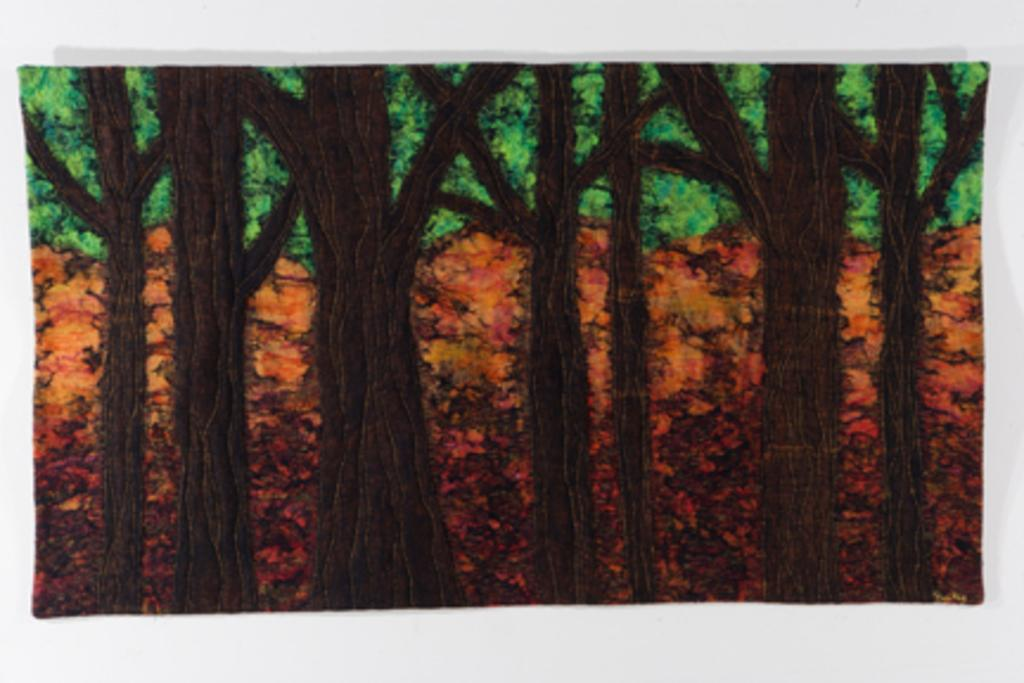What is the main subject of the painting in the image? The painting depicts trees. What colors can be seen in the painting? The provided facts do not mention specific colors in the painting, only that it depicts trees. What type of vegetation is visible behind the painting? There are orange color plants visible behind the painting. What type of prison is depicted in the painting? There is no prison depicted in the painting; it features trees. What is the name of the arch visible behind the painting? There is no arch visible behind the painting; only orange color plants are present. 